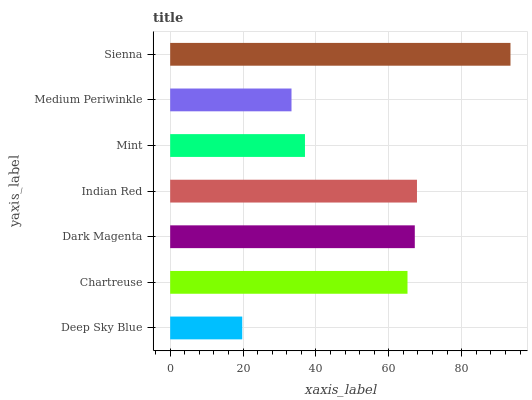Is Deep Sky Blue the minimum?
Answer yes or no. Yes. Is Sienna the maximum?
Answer yes or no. Yes. Is Chartreuse the minimum?
Answer yes or no. No. Is Chartreuse the maximum?
Answer yes or no. No. Is Chartreuse greater than Deep Sky Blue?
Answer yes or no. Yes. Is Deep Sky Blue less than Chartreuse?
Answer yes or no. Yes. Is Deep Sky Blue greater than Chartreuse?
Answer yes or no. No. Is Chartreuse less than Deep Sky Blue?
Answer yes or no. No. Is Chartreuse the high median?
Answer yes or no. Yes. Is Chartreuse the low median?
Answer yes or no. Yes. Is Deep Sky Blue the high median?
Answer yes or no. No. Is Deep Sky Blue the low median?
Answer yes or no. No. 